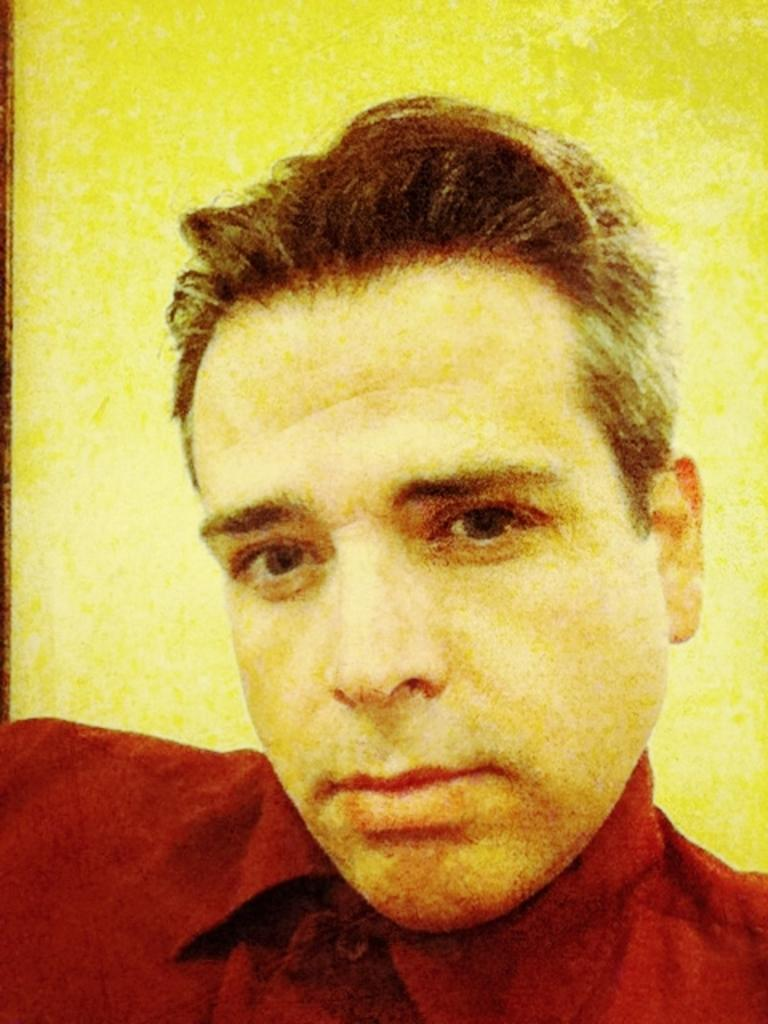What is the main subject of the image? There is a person's face in the image. What can be seen in the background of the image? There is a wall in the background of the image. What type of pen is the person holding in the image? There is no pen present in the image; it only shows a person's face and a wall in the background. Is the person playing a guitar in the image? There is no guitar present in the image; it only shows a person's face and a wall in the background. 